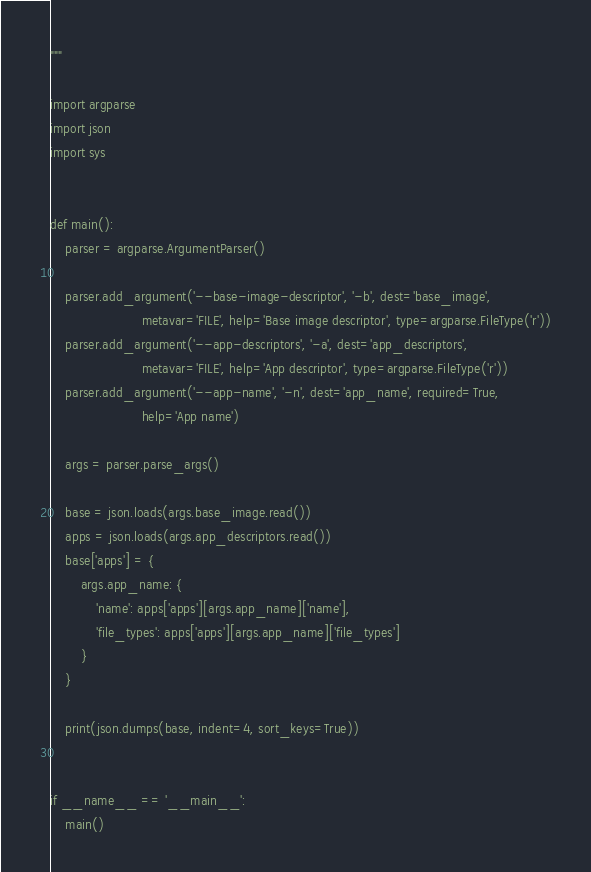<code> <loc_0><loc_0><loc_500><loc_500><_Python_>"""

import argparse
import json
import sys


def main():
    parser = argparse.ArgumentParser()

    parser.add_argument('--base-image-descriptor', '-b', dest='base_image',
                        metavar='FILE', help='Base image descriptor', type=argparse.FileType('r'))
    parser.add_argument('--app-descriptors', '-a', dest='app_descriptors',
                        metavar='FILE', help='App descriptor', type=argparse.FileType('r'))
    parser.add_argument('--app-name', '-n', dest='app_name', required=True,
                        help='App name')

    args = parser.parse_args()

    base = json.loads(args.base_image.read())
    apps = json.loads(args.app_descriptors.read())
    base['apps'] = {
        args.app_name: {
            'name': apps['apps'][args.app_name]['name'],
            'file_types': apps['apps'][args.app_name]['file_types']
        }
    }

    print(json.dumps(base, indent=4, sort_keys=True))


if __name__ == '__main__':
    main()
</code> 